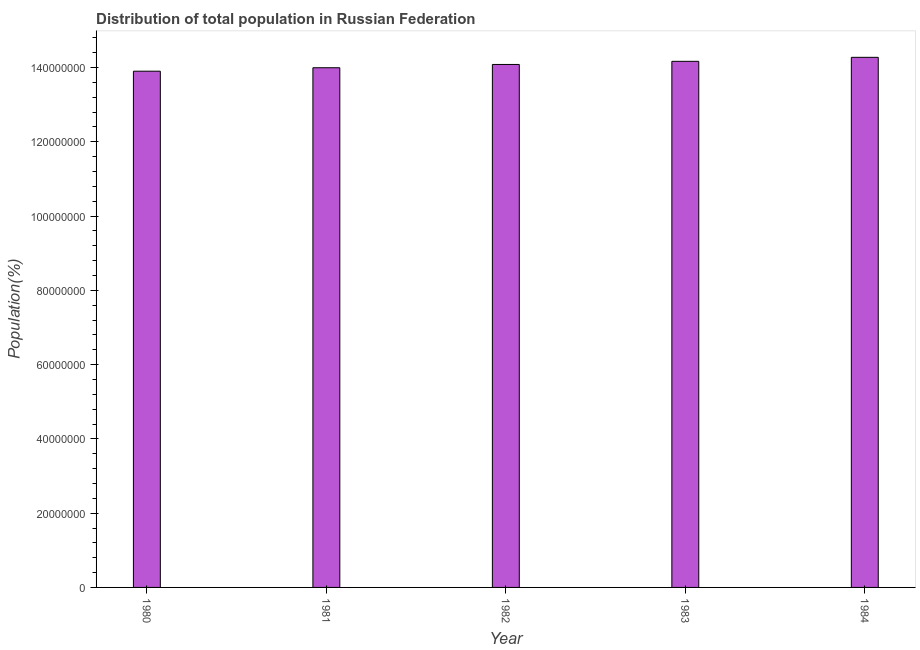Does the graph contain any zero values?
Your response must be concise. No. Does the graph contain grids?
Your response must be concise. No. What is the title of the graph?
Give a very brief answer. Distribution of total population in Russian Federation . What is the label or title of the Y-axis?
Give a very brief answer. Population(%). What is the population in 1982?
Give a very brief answer. 1.41e+08. Across all years, what is the maximum population?
Your response must be concise. 1.43e+08. Across all years, what is the minimum population?
Provide a short and direct response. 1.39e+08. What is the sum of the population?
Make the answer very short. 7.04e+08. What is the difference between the population in 1980 and 1984?
Provide a succinct answer. -3.74e+06. What is the average population per year?
Provide a succinct answer. 1.41e+08. What is the median population?
Your response must be concise. 1.41e+08. In how many years, is the population greater than 96000000 %?
Offer a very short reply. 5. What is the ratio of the population in 1980 to that in 1983?
Provide a succinct answer. 0.98. Is the difference between the population in 1980 and 1981 greater than the difference between any two years?
Give a very brief answer. No. What is the difference between the highest and the second highest population?
Ensure brevity in your answer.  1.08e+06. What is the difference between the highest and the lowest population?
Your answer should be very brief. 3.74e+06. In how many years, is the population greater than the average population taken over all years?
Your answer should be very brief. 2. How many years are there in the graph?
Your answer should be compact. 5. What is the difference between two consecutive major ticks on the Y-axis?
Your response must be concise. 2.00e+07. What is the Population(%) in 1980?
Offer a very short reply. 1.39e+08. What is the Population(%) of 1981?
Ensure brevity in your answer.  1.40e+08. What is the Population(%) in 1982?
Your response must be concise. 1.41e+08. What is the Population(%) in 1983?
Provide a short and direct response. 1.42e+08. What is the Population(%) in 1984?
Your answer should be compact. 1.43e+08. What is the difference between the Population(%) in 1980 and 1981?
Provide a short and direct response. -9.31e+05. What is the difference between the Population(%) in 1980 and 1982?
Keep it short and to the point. -1.81e+06. What is the difference between the Population(%) in 1980 and 1983?
Your response must be concise. -2.66e+06. What is the difference between the Population(%) in 1980 and 1984?
Make the answer very short. -3.74e+06. What is the difference between the Population(%) in 1981 and 1982?
Keep it short and to the point. -8.82e+05. What is the difference between the Population(%) in 1981 and 1983?
Keep it short and to the point. -1.73e+06. What is the difference between the Population(%) in 1981 and 1984?
Provide a short and direct response. -2.80e+06. What is the difference between the Population(%) in 1982 and 1983?
Give a very brief answer. -8.45e+05. What is the difference between the Population(%) in 1982 and 1984?
Your answer should be very brief. -1.92e+06. What is the difference between the Population(%) in 1983 and 1984?
Your response must be concise. -1.08e+06. What is the ratio of the Population(%) in 1981 to that in 1982?
Keep it short and to the point. 0.99. What is the ratio of the Population(%) in 1981 to that in 1983?
Provide a short and direct response. 0.99. What is the ratio of the Population(%) in 1983 to that in 1984?
Make the answer very short. 0.99. 